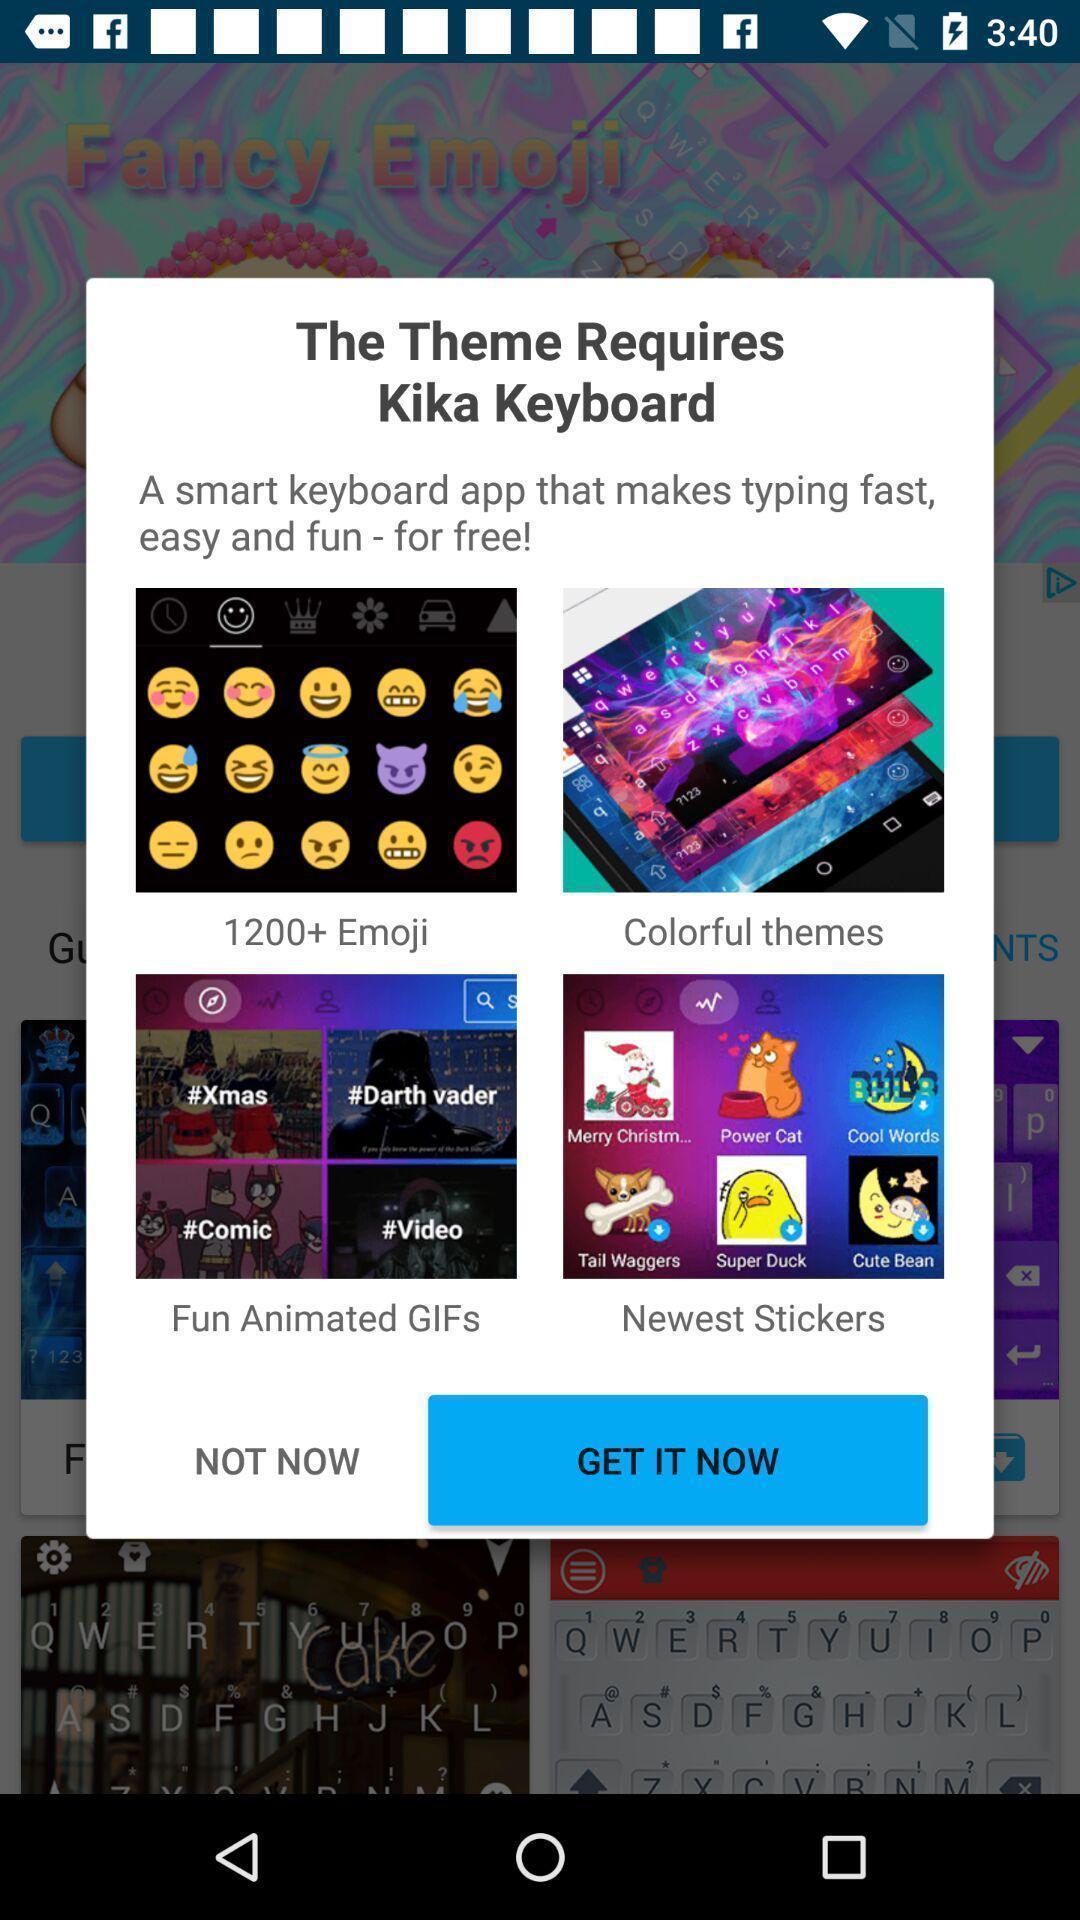Explain what's happening in this screen capture. Popup showing about different options. 